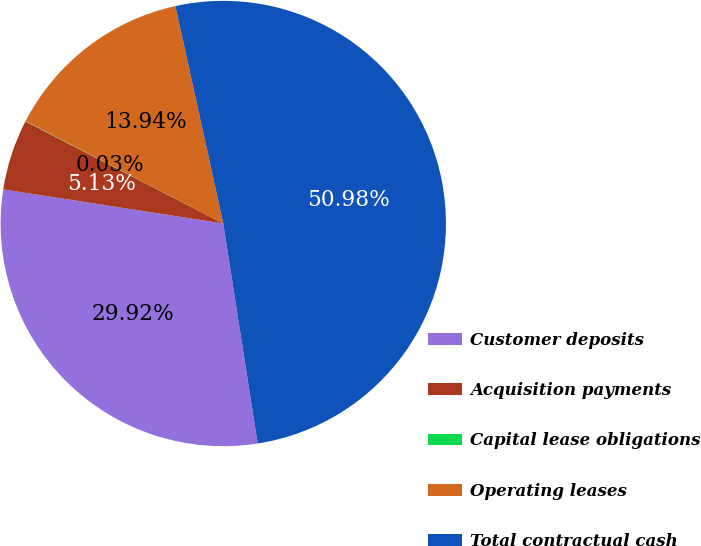Convert chart to OTSL. <chart><loc_0><loc_0><loc_500><loc_500><pie_chart><fcel>Customer deposits<fcel>Acquisition payments<fcel>Capital lease obligations<fcel>Operating leases<fcel>Total contractual cash<nl><fcel>29.92%<fcel>5.13%<fcel>0.03%<fcel>13.94%<fcel>50.98%<nl></chart> 